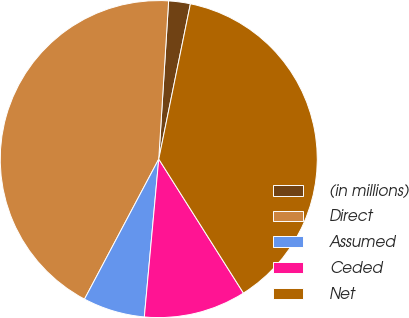Convert chart. <chart><loc_0><loc_0><loc_500><loc_500><pie_chart><fcel>(in millions)<fcel>Direct<fcel>Assumed<fcel>Ceded<fcel>Net<nl><fcel>2.21%<fcel>43.23%<fcel>6.31%<fcel>10.42%<fcel>37.83%<nl></chart> 